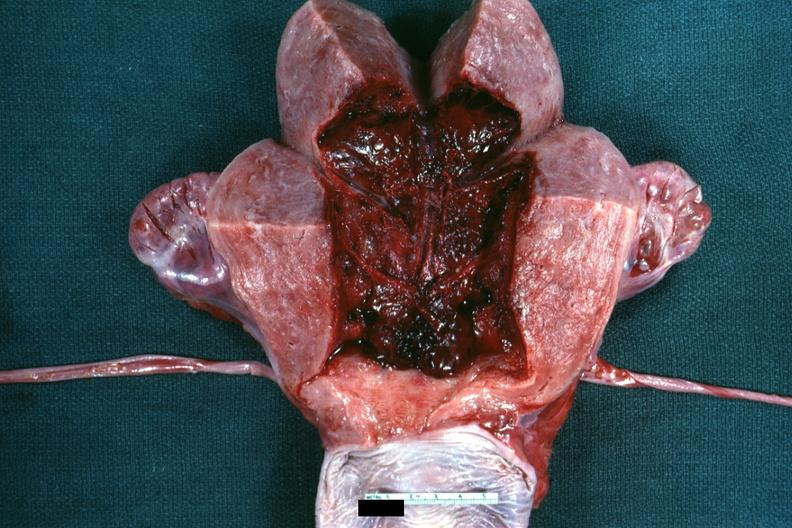where does this belong to?
Answer the question using a single word or phrase. Female reproductive system 